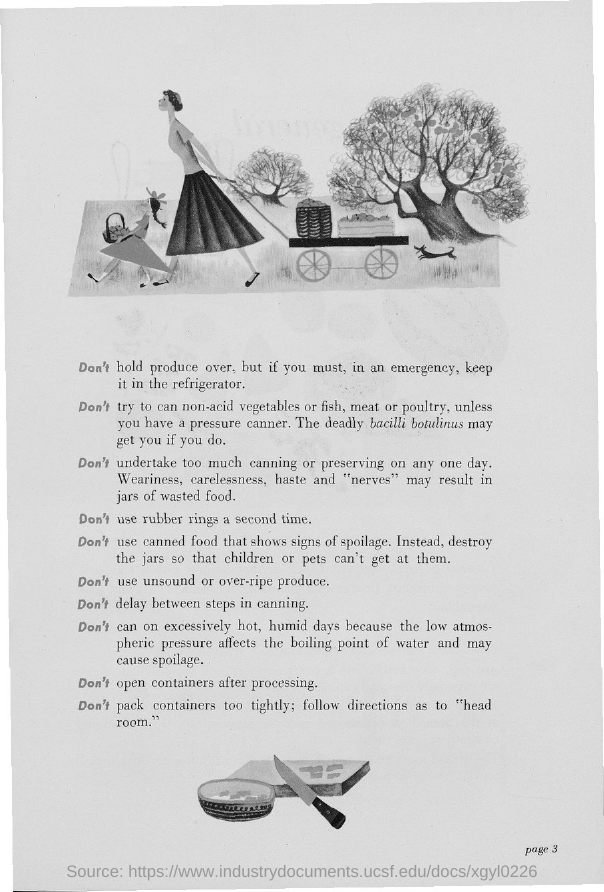List a handful of essential elements in this visual. The page number is 3, as declared. 